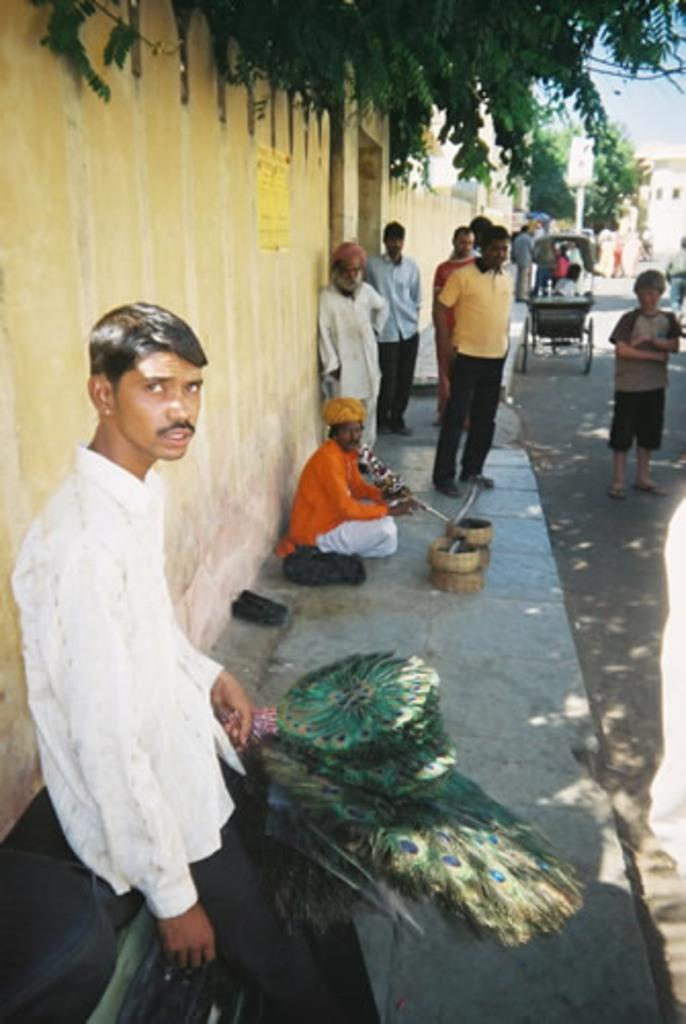What type of structure can be seen in the image? There is a wall in the image. What natural elements are present in the image? There are trees in the image. What mode of transportation is visible in the image? There is a vehicle in the image. What object is used for carrying items in the image? There is a basket in the image. Who or what is present in the image? There are people present in the image. What month is it in the image? The month cannot be determined from the image, as it does not contain any information about the time of year. How does the digestion process work for the people in the image? The digestion process for the people in the image cannot be determined from the image, as it does not provide any information about their diet or health. 